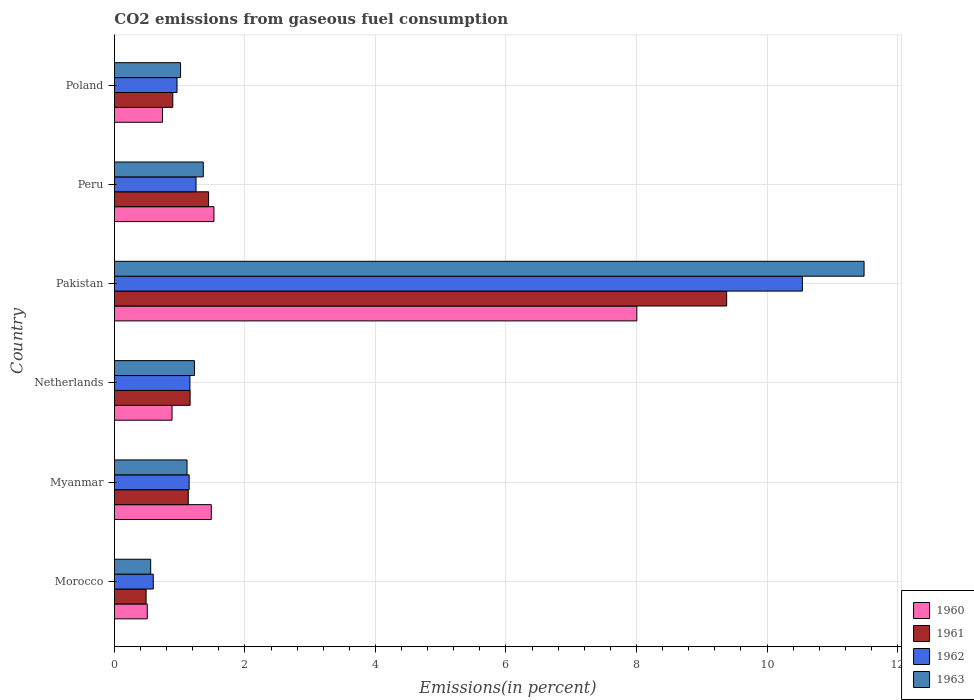Are the number of bars on each tick of the Y-axis equal?
Offer a very short reply. Yes. How many bars are there on the 1st tick from the bottom?
Provide a short and direct response. 4. What is the total CO2 emitted in 1962 in Myanmar?
Provide a short and direct response. 1.15. Across all countries, what is the maximum total CO2 emitted in 1961?
Provide a succinct answer. 9.38. Across all countries, what is the minimum total CO2 emitted in 1961?
Your response must be concise. 0.49. In which country was the total CO2 emitted in 1960 minimum?
Keep it short and to the point. Morocco. What is the total total CO2 emitted in 1960 in the graph?
Your answer should be compact. 13.14. What is the difference between the total CO2 emitted in 1960 in Netherlands and that in Poland?
Your answer should be compact. 0.15. What is the difference between the total CO2 emitted in 1960 in Morocco and the total CO2 emitted in 1963 in Poland?
Offer a very short reply. -0.51. What is the average total CO2 emitted in 1961 per country?
Make the answer very short. 2.42. What is the difference between the total CO2 emitted in 1961 and total CO2 emitted in 1960 in Pakistan?
Your response must be concise. 1.38. In how many countries, is the total CO2 emitted in 1963 greater than 7.6 %?
Your answer should be very brief. 1. What is the ratio of the total CO2 emitted in 1960 in Morocco to that in Peru?
Your answer should be very brief. 0.33. Is the total CO2 emitted in 1961 in Netherlands less than that in Peru?
Offer a terse response. Yes. Is the difference between the total CO2 emitted in 1961 in Morocco and Peru greater than the difference between the total CO2 emitted in 1960 in Morocco and Peru?
Ensure brevity in your answer.  Yes. What is the difference between the highest and the second highest total CO2 emitted in 1961?
Your answer should be very brief. 7.94. What is the difference between the highest and the lowest total CO2 emitted in 1962?
Ensure brevity in your answer.  9.95. In how many countries, is the total CO2 emitted in 1961 greater than the average total CO2 emitted in 1961 taken over all countries?
Give a very brief answer. 1. Is the sum of the total CO2 emitted in 1961 in Myanmar and Peru greater than the maximum total CO2 emitted in 1962 across all countries?
Give a very brief answer. No. What does the 1st bar from the top in Netherlands represents?
Offer a terse response. 1963. What does the 3rd bar from the bottom in Pakistan represents?
Offer a very short reply. 1962. Are the values on the major ticks of X-axis written in scientific E-notation?
Offer a very short reply. No. Where does the legend appear in the graph?
Offer a very short reply. Bottom right. How many legend labels are there?
Your answer should be compact. 4. What is the title of the graph?
Your response must be concise. CO2 emissions from gaseous fuel consumption. Does "1961" appear as one of the legend labels in the graph?
Give a very brief answer. Yes. What is the label or title of the X-axis?
Provide a short and direct response. Emissions(in percent). What is the label or title of the Y-axis?
Your response must be concise. Country. What is the Emissions(in percent) in 1960 in Morocco?
Keep it short and to the point. 0.5. What is the Emissions(in percent) of 1961 in Morocco?
Your answer should be very brief. 0.49. What is the Emissions(in percent) in 1962 in Morocco?
Your response must be concise. 0.6. What is the Emissions(in percent) of 1963 in Morocco?
Give a very brief answer. 0.56. What is the Emissions(in percent) of 1960 in Myanmar?
Offer a very short reply. 1.48. What is the Emissions(in percent) of 1961 in Myanmar?
Make the answer very short. 1.13. What is the Emissions(in percent) in 1962 in Myanmar?
Offer a very short reply. 1.15. What is the Emissions(in percent) in 1963 in Myanmar?
Provide a short and direct response. 1.11. What is the Emissions(in percent) of 1960 in Netherlands?
Provide a short and direct response. 0.88. What is the Emissions(in percent) of 1961 in Netherlands?
Ensure brevity in your answer.  1.16. What is the Emissions(in percent) of 1962 in Netherlands?
Ensure brevity in your answer.  1.16. What is the Emissions(in percent) in 1963 in Netherlands?
Give a very brief answer. 1.23. What is the Emissions(in percent) of 1960 in Pakistan?
Make the answer very short. 8.01. What is the Emissions(in percent) of 1961 in Pakistan?
Offer a very short reply. 9.38. What is the Emissions(in percent) of 1962 in Pakistan?
Your answer should be compact. 10.54. What is the Emissions(in percent) of 1963 in Pakistan?
Make the answer very short. 11.49. What is the Emissions(in percent) of 1960 in Peru?
Your answer should be very brief. 1.53. What is the Emissions(in percent) in 1961 in Peru?
Make the answer very short. 1.44. What is the Emissions(in percent) of 1962 in Peru?
Offer a terse response. 1.25. What is the Emissions(in percent) of 1963 in Peru?
Your answer should be very brief. 1.36. What is the Emissions(in percent) of 1960 in Poland?
Provide a short and direct response. 0.74. What is the Emissions(in percent) in 1961 in Poland?
Provide a succinct answer. 0.89. What is the Emissions(in percent) in 1962 in Poland?
Make the answer very short. 0.96. What is the Emissions(in percent) in 1963 in Poland?
Your answer should be very brief. 1.01. Across all countries, what is the maximum Emissions(in percent) of 1960?
Provide a short and direct response. 8.01. Across all countries, what is the maximum Emissions(in percent) of 1961?
Give a very brief answer. 9.38. Across all countries, what is the maximum Emissions(in percent) in 1962?
Make the answer very short. 10.54. Across all countries, what is the maximum Emissions(in percent) of 1963?
Give a very brief answer. 11.49. Across all countries, what is the minimum Emissions(in percent) of 1960?
Provide a succinct answer. 0.5. Across all countries, what is the minimum Emissions(in percent) in 1961?
Your response must be concise. 0.49. Across all countries, what is the minimum Emissions(in percent) in 1962?
Make the answer very short. 0.6. Across all countries, what is the minimum Emissions(in percent) of 1963?
Provide a succinct answer. 0.56. What is the total Emissions(in percent) of 1960 in the graph?
Give a very brief answer. 13.14. What is the total Emissions(in percent) in 1961 in the graph?
Provide a short and direct response. 14.5. What is the total Emissions(in percent) in 1962 in the graph?
Offer a terse response. 15.65. What is the total Emissions(in percent) of 1963 in the graph?
Give a very brief answer. 16.76. What is the difference between the Emissions(in percent) of 1960 in Morocco and that in Myanmar?
Provide a short and direct response. -0.98. What is the difference between the Emissions(in percent) in 1961 in Morocco and that in Myanmar?
Offer a terse response. -0.65. What is the difference between the Emissions(in percent) of 1962 in Morocco and that in Myanmar?
Provide a succinct answer. -0.55. What is the difference between the Emissions(in percent) in 1963 in Morocco and that in Myanmar?
Your answer should be very brief. -0.56. What is the difference between the Emissions(in percent) of 1960 in Morocco and that in Netherlands?
Offer a terse response. -0.38. What is the difference between the Emissions(in percent) of 1961 in Morocco and that in Netherlands?
Your answer should be compact. -0.67. What is the difference between the Emissions(in percent) of 1962 in Morocco and that in Netherlands?
Make the answer very short. -0.56. What is the difference between the Emissions(in percent) in 1963 in Morocco and that in Netherlands?
Ensure brevity in your answer.  -0.67. What is the difference between the Emissions(in percent) of 1960 in Morocco and that in Pakistan?
Your response must be concise. -7.5. What is the difference between the Emissions(in percent) of 1961 in Morocco and that in Pakistan?
Your answer should be very brief. -8.9. What is the difference between the Emissions(in percent) in 1962 in Morocco and that in Pakistan?
Provide a short and direct response. -9.95. What is the difference between the Emissions(in percent) of 1963 in Morocco and that in Pakistan?
Give a very brief answer. -10.93. What is the difference between the Emissions(in percent) of 1960 in Morocco and that in Peru?
Make the answer very short. -1.02. What is the difference between the Emissions(in percent) in 1961 in Morocco and that in Peru?
Give a very brief answer. -0.96. What is the difference between the Emissions(in percent) of 1962 in Morocco and that in Peru?
Provide a succinct answer. -0.66. What is the difference between the Emissions(in percent) of 1963 in Morocco and that in Peru?
Offer a terse response. -0.81. What is the difference between the Emissions(in percent) of 1960 in Morocco and that in Poland?
Your response must be concise. -0.23. What is the difference between the Emissions(in percent) in 1961 in Morocco and that in Poland?
Your response must be concise. -0.41. What is the difference between the Emissions(in percent) in 1962 in Morocco and that in Poland?
Your answer should be compact. -0.36. What is the difference between the Emissions(in percent) in 1963 in Morocco and that in Poland?
Give a very brief answer. -0.46. What is the difference between the Emissions(in percent) of 1960 in Myanmar and that in Netherlands?
Offer a very short reply. 0.6. What is the difference between the Emissions(in percent) of 1961 in Myanmar and that in Netherlands?
Your response must be concise. -0.03. What is the difference between the Emissions(in percent) in 1962 in Myanmar and that in Netherlands?
Offer a very short reply. -0.01. What is the difference between the Emissions(in percent) of 1963 in Myanmar and that in Netherlands?
Provide a short and direct response. -0.11. What is the difference between the Emissions(in percent) of 1960 in Myanmar and that in Pakistan?
Provide a short and direct response. -6.52. What is the difference between the Emissions(in percent) of 1961 in Myanmar and that in Pakistan?
Your answer should be compact. -8.25. What is the difference between the Emissions(in percent) of 1962 in Myanmar and that in Pakistan?
Provide a short and direct response. -9.4. What is the difference between the Emissions(in percent) of 1963 in Myanmar and that in Pakistan?
Your answer should be compact. -10.37. What is the difference between the Emissions(in percent) of 1960 in Myanmar and that in Peru?
Provide a succinct answer. -0.04. What is the difference between the Emissions(in percent) of 1961 in Myanmar and that in Peru?
Offer a very short reply. -0.31. What is the difference between the Emissions(in percent) of 1962 in Myanmar and that in Peru?
Keep it short and to the point. -0.11. What is the difference between the Emissions(in percent) of 1963 in Myanmar and that in Peru?
Keep it short and to the point. -0.25. What is the difference between the Emissions(in percent) of 1960 in Myanmar and that in Poland?
Make the answer very short. 0.75. What is the difference between the Emissions(in percent) of 1961 in Myanmar and that in Poland?
Ensure brevity in your answer.  0.24. What is the difference between the Emissions(in percent) of 1962 in Myanmar and that in Poland?
Your answer should be compact. 0.19. What is the difference between the Emissions(in percent) in 1963 in Myanmar and that in Poland?
Keep it short and to the point. 0.1. What is the difference between the Emissions(in percent) in 1960 in Netherlands and that in Pakistan?
Offer a very short reply. -7.12. What is the difference between the Emissions(in percent) of 1961 in Netherlands and that in Pakistan?
Give a very brief answer. -8.22. What is the difference between the Emissions(in percent) in 1962 in Netherlands and that in Pakistan?
Your answer should be very brief. -9.38. What is the difference between the Emissions(in percent) of 1963 in Netherlands and that in Pakistan?
Ensure brevity in your answer.  -10.26. What is the difference between the Emissions(in percent) of 1960 in Netherlands and that in Peru?
Provide a short and direct response. -0.64. What is the difference between the Emissions(in percent) in 1961 in Netherlands and that in Peru?
Provide a short and direct response. -0.28. What is the difference between the Emissions(in percent) of 1962 in Netherlands and that in Peru?
Your answer should be compact. -0.09. What is the difference between the Emissions(in percent) of 1963 in Netherlands and that in Peru?
Offer a terse response. -0.14. What is the difference between the Emissions(in percent) in 1960 in Netherlands and that in Poland?
Keep it short and to the point. 0.15. What is the difference between the Emissions(in percent) of 1961 in Netherlands and that in Poland?
Your answer should be very brief. 0.27. What is the difference between the Emissions(in percent) in 1962 in Netherlands and that in Poland?
Provide a short and direct response. 0.2. What is the difference between the Emissions(in percent) of 1963 in Netherlands and that in Poland?
Keep it short and to the point. 0.21. What is the difference between the Emissions(in percent) in 1960 in Pakistan and that in Peru?
Give a very brief answer. 6.48. What is the difference between the Emissions(in percent) in 1961 in Pakistan and that in Peru?
Your answer should be very brief. 7.94. What is the difference between the Emissions(in percent) of 1962 in Pakistan and that in Peru?
Ensure brevity in your answer.  9.29. What is the difference between the Emissions(in percent) in 1963 in Pakistan and that in Peru?
Give a very brief answer. 10.13. What is the difference between the Emissions(in percent) in 1960 in Pakistan and that in Poland?
Ensure brevity in your answer.  7.27. What is the difference between the Emissions(in percent) in 1961 in Pakistan and that in Poland?
Provide a succinct answer. 8.49. What is the difference between the Emissions(in percent) in 1962 in Pakistan and that in Poland?
Give a very brief answer. 9.58. What is the difference between the Emissions(in percent) of 1963 in Pakistan and that in Poland?
Give a very brief answer. 10.47. What is the difference between the Emissions(in percent) in 1960 in Peru and that in Poland?
Keep it short and to the point. 0.79. What is the difference between the Emissions(in percent) in 1961 in Peru and that in Poland?
Make the answer very short. 0.55. What is the difference between the Emissions(in percent) of 1962 in Peru and that in Poland?
Your response must be concise. 0.29. What is the difference between the Emissions(in percent) of 1963 in Peru and that in Poland?
Make the answer very short. 0.35. What is the difference between the Emissions(in percent) of 1960 in Morocco and the Emissions(in percent) of 1961 in Myanmar?
Make the answer very short. -0.63. What is the difference between the Emissions(in percent) in 1960 in Morocco and the Emissions(in percent) in 1962 in Myanmar?
Give a very brief answer. -0.64. What is the difference between the Emissions(in percent) in 1960 in Morocco and the Emissions(in percent) in 1963 in Myanmar?
Provide a succinct answer. -0.61. What is the difference between the Emissions(in percent) of 1961 in Morocco and the Emissions(in percent) of 1962 in Myanmar?
Ensure brevity in your answer.  -0.66. What is the difference between the Emissions(in percent) of 1961 in Morocco and the Emissions(in percent) of 1963 in Myanmar?
Your response must be concise. -0.63. What is the difference between the Emissions(in percent) of 1962 in Morocco and the Emissions(in percent) of 1963 in Myanmar?
Offer a very short reply. -0.52. What is the difference between the Emissions(in percent) of 1960 in Morocco and the Emissions(in percent) of 1961 in Netherlands?
Offer a terse response. -0.66. What is the difference between the Emissions(in percent) of 1960 in Morocco and the Emissions(in percent) of 1962 in Netherlands?
Your answer should be compact. -0.65. What is the difference between the Emissions(in percent) of 1960 in Morocco and the Emissions(in percent) of 1963 in Netherlands?
Provide a succinct answer. -0.72. What is the difference between the Emissions(in percent) in 1961 in Morocco and the Emissions(in percent) in 1962 in Netherlands?
Provide a short and direct response. -0.67. What is the difference between the Emissions(in percent) in 1961 in Morocco and the Emissions(in percent) in 1963 in Netherlands?
Offer a very short reply. -0.74. What is the difference between the Emissions(in percent) of 1962 in Morocco and the Emissions(in percent) of 1963 in Netherlands?
Your response must be concise. -0.63. What is the difference between the Emissions(in percent) in 1960 in Morocco and the Emissions(in percent) in 1961 in Pakistan?
Provide a succinct answer. -8.88. What is the difference between the Emissions(in percent) of 1960 in Morocco and the Emissions(in percent) of 1962 in Pakistan?
Give a very brief answer. -10.04. What is the difference between the Emissions(in percent) in 1960 in Morocco and the Emissions(in percent) in 1963 in Pakistan?
Your response must be concise. -10.98. What is the difference between the Emissions(in percent) in 1961 in Morocco and the Emissions(in percent) in 1962 in Pakistan?
Your answer should be compact. -10.06. What is the difference between the Emissions(in percent) of 1961 in Morocco and the Emissions(in percent) of 1963 in Pakistan?
Provide a short and direct response. -11. What is the difference between the Emissions(in percent) of 1962 in Morocco and the Emissions(in percent) of 1963 in Pakistan?
Your answer should be compact. -10.89. What is the difference between the Emissions(in percent) in 1960 in Morocco and the Emissions(in percent) in 1961 in Peru?
Make the answer very short. -0.94. What is the difference between the Emissions(in percent) of 1960 in Morocco and the Emissions(in percent) of 1962 in Peru?
Offer a very short reply. -0.75. What is the difference between the Emissions(in percent) of 1960 in Morocco and the Emissions(in percent) of 1963 in Peru?
Your response must be concise. -0.86. What is the difference between the Emissions(in percent) of 1961 in Morocco and the Emissions(in percent) of 1962 in Peru?
Provide a succinct answer. -0.77. What is the difference between the Emissions(in percent) of 1961 in Morocco and the Emissions(in percent) of 1963 in Peru?
Your answer should be very brief. -0.88. What is the difference between the Emissions(in percent) in 1962 in Morocco and the Emissions(in percent) in 1963 in Peru?
Your answer should be compact. -0.77. What is the difference between the Emissions(in percent) of 1960 in Morocco and the Emissions(in percent) of 1961 in Poland?
Give a very brief answer. -0.39. What is the difference between the Emissions(in percent) in 1960 in Morocco and the Emissions(in percent) in 1962 in Poland?
Provide a short and direct response. -0.46. What is the difference between the Emissions(in percent) in 1960 in Morocco and the Emissions(in percent) in 1963 in Poland?
Your response must be concise. -0.51. What is the difference between the Emissions(in percent) of 1961 in Morocco and the Emissions(in percent) of 1962 in Poland?
Provide a short and direct response. -0.47. What is the difference between the Emissions(in percent) in 1961 in Morocco and the Emissions(in percent) in 1963 in Poland?
Make the answer very short. -0.53. What is the difference between the Emissions(in percent) of 1962 in Morocco and the Emissions(in percent) of 1963 in Poland?
Keep it short and to the point. -0.42. What is the difference between the Emissions(in percent) of 1960 in Myanmar and the Emissions(in percent) of 1961 in Netherlands?
Your response must be concise. 0.32. What is the difference between the Emissions(in percent) of 1960 in Myanmar and the Emissions(in percent) of 1962 in Netherlands?
Offer a terse response. 0.33. What is the difference between the Emissions(in percent) of 1960 in Myanmar and the Emissions(in percent) of 1963 in Netherlands?
Keep it short and to the point. 0.26. What is the difference between the Emissions(in percent) of 1961 in Myanmar and the Emissions(in percent) of 1962 in Netherlands?
Your answer should be very brief. -0.03. What is the difference between the Emissions(in percent) in 1961 in Myanmar and the Emissions(in percent) in 1963 in Netherlands?
Give a very brief answer. -0.09. What is the difference between the Emissions(in percent) of 1962 in Myanmar and the Emissions(in percent) of 1963 in Netherlands?
Offer a terse response. -0.08. What is the difference between the Emissions(in percent) of 1960 in Myanmar and the Emissions(in percent) of 1961 in Pakistan?
Offer a terse response. -7.9. What is the difference between the Emissions(in percent) in 1960 in Myanmar and the Emissions(in percent) in 1962 in Pakistan?
Your response must be concise. -9.06. What is the difference between the Emissions(in percent) in 1960 in Myanmar and the Emissions(in percent) in 1963 in Pakistan?
Give a very brief answer. -10. What is the difference between the Emissions(in percent) in 1961 in Myanmar and the Emissions(in percent) in 1962 in Pakistan?
Offer a terse response. -9.41. What is the difference between the Emissions(in percent) in 1961 in Myanmar and the Emissions(in percent) in 1963 in Pakistan?
Ensure brevity in your answer.  -10.36. What is the difference between the Emissions(in percent) in 1962 in Myanmar and the Emissions(in percent) in 1963 in Pakistan?
Offer a terse response. -10.34. What is the difference between the Emissions(in percent) of 1960 in Myanmar and the Emissions(in percent) of 1961 in Peru?
Your response must be concise. 0.04. What is the difference between the Emissions(in percent) of 1960 in Myanmar and the Emissions(in percent) of 1962 in Peru?
Give a very brief answer. 0.23. What is the difference between the Emissions(in percent) of 1960 in Myanmar and the Emissions(in percent) of 1963 in Peru?
Offer a terse response. 0.12. What is the difference between the Emissions(in percent) of 1961 in Myanmar and the Emissions(in percent) of 1962 in Peru?
Keep it short and to the point. -0.12. What is the difference between the Emissions(in percent) in 1961 in Myanmar and the Emissions(in percent) in 1963 in Peru?
Your answer should be compact. -0.23. What is the difference between the Emissions(in percent) in 1962 in Myanmar and the Emissions(in percent) in 1963 in Peru?
Provide a short and direct response. -0.22. What is the difference between the Emissions(in percent) in 1960 in Myanmar and the Emissions(in percent) in 1961 in Poland?
Provide a short and direct response. 0.59. What is the difference between the Emissions(in percent) of 1960 in Myanmar and the Emissions(in percent) of 1962 in Poland?
Provide a short and direct response. 0.53. What is the difference between the Emissions(in percent) in 1960 in Myanmar and the Emissions(in percent) in 1963 in Poland?
Keep it short and to the point. 0.47. What is the difference between the Emissions(in percent) of 1961 in Myanmar and the Emissions(in percent) of 1962 in Poland?
Make the answer very short. 0.17. What is the difference between the Emissions(in percent) in 1961 in Myanmar and the Emissions(in percent) in 1963 in Poland?
Your answer should be very brief. 0.12. What is the difference between the Emissions(in percent) in 1962 in Myanmar and the Emissions(in percent) in 1963 in Poland?
Your response must be concise. 0.13. What is the difference between the Emissions(in percent) in 1960 in Netherlands and the Emissions(in percent) in 1961 in Pakistan?
Make the answer very short. -8.5. What is the difference between the Emissions(in percent) in 1960 in Netherlands and the Emissions(in percent) in 1962 in Pakistan?
Offer a very short reply. -9.66. What is the difference between the Emissions(in percent) of 1960 in Netherlands and the Emissions(in percent) of 1963 in Pakistan?
Give a very brief answer. -10.6. What is the difference between the Emissions(in percent) of 1961 in Netherlands and the Emissions(in percent) of 1962 in Pakistan?
Keep it short and to the point. -9.38. What is the difference between the Emissions(in percent) in 1961 in Netherlands and the Emissions(in percent) in 1963 in Pakistan?
Offer a very short reply. -10.33. What is the difference between the Emissions(in percent) in 1962 in Netherlands and the Emissions(in percent) in 1963 in Pakistan?
Give a very brief answer. -10.33. What is the difference between the Emissions(in percent) of 1960 in Netherlands and the Emissions(in percent) of 1961 in Peru?
Make the answer very short. -0.56. What is the difference between the Emissions(in percent) in 1960 in Netherlands and the Emissions(in percent) in 1962 in Peru?
Offer a terse response. -0.37. What is the difference between the Emissions(in percent) in 1960 in Netherlands and the Emissions(in percent) in 1963 in Peru?
Give a very brief answer. -0.48. What is the difference between the Emissions(in percent) of 1961 in Netherlands and the Emissions(in percent) of 1962 in Peru?
Offer a terse response. -0.09. What is the difference between the Emissions(in percent) of 1961 in Netherlands and the Emissions(in percent) of 1963 in Peru?
Keep it short and to the point. -0.2. What is the difference between the Emissions(in percent) of 1962 in Netherlands and the Emissions(in percent) of 1963 in Peru?
Make the answer very short. -0.2. What is the difference between the Emissions(in percent) of 1960 in Netherlands and the Emissions(in percent) of 1961 in Poland?
Provide a short and direct response. -0.01. What is the difference between the Emissions(in percent) in 1960 in Netherlands and the Emissions(in percent) in 1962 in Poland?
Ensure brevity in your answer.  -0.08. What is the difference between the Emissions(in percent) in 1960 in Netherlands and the Emissions(in percent) in 1963 in Poland?
Offer a very short reply. -0.13. What is the difference between the Emissions(in percent) in 1961 in Netherlands and the Emissions(in percent) in 1962 in Poland?
Provide a succinct answer. 0.2. What is the difference between the Emissions(in percent) in 1961 in Netherlands and the Emissions(in percent) in 1963 in Poland?
Keep it short and to the point. 0.15. What is the difference between the Emissions(in percent) of 1962 in Netherlands and the Emissions(in percent) of 1963 in Poland?
Offer a very short reply. 0.14. What is the difference between the Emissions(in percent) in 1960 in Pakistan and the Emissions(in percent) in 1961 in Peru?
Your response must be concise. 6.56. What is the difference between the Emissions(in percent) in 1960 in Pakistan and the Emissions(in percent) in 1962 in Peru?
Your answer should be compact. 6.75. What is the difference between the Emissions(in percent) of 1960 in Pakistan and the Emissions(in percent) of 1963 in Peru?
Make the answer very short. 6.64. What is the difference between the Emissions(in percent) of 1961 in Pakistan and the Emissions(in percent) of 1962 in Peru?
Provide a succinct answer. 8.13. What is the difference between the Emissions(in percent) of 1961 in Pakistan and the Emissions(in percent) of 1963 in Peru?
Make the answer very short. 8.02. What is the difference between the Emissions(in percent) of 1962 in Pakistan and the Emissions(in percent) of 1963 in Peru?
Ensure brevity in your answer.  9.18. What is the difference between the Emissions(in percent) of 1960 in Pakistan and the Emissions(in percent) of 1961 in Poland?
Keep it short and to the point. 7.11. What is the difference between the Emissions(in percent) in 1960 in Pakistan and the Emissions(in percent) in 1962 in Poland?
Ensure brevity in your answer.  7.05. What is the difference between the Emissions(in percent) in 1960 in Pakistan and the Emissions(in percent) in 1963 in Poland?
Offer a terse response. 6.99. What is the difference between the Emissions(in percent) in 1961 in Pakistan and the Emissions(in percent) in 1962 in Poland?
Offer a very short reply. 8.42. What is the difference between the Emissions(in percent) of 1961 in Pakistan and the Emissions(in percent) of 1963 in Poland?
Keep it short and to the point. 8.37. What is the difference between the Emissions(in percent) of 1962 in Pakistan and the Emissions(in percent) of 1963 in Poland?
Your answer should be compact. 9.53. What is the difference between the Emissions(in percent) in 1960 in Peru and the Emissions(in percent) in 1961 in Poland?
Your answer should be very brief. 0.63. What is the difference between the Emissions(in percent) of 1960 in Peru and the Emissions(in percent) of 1962 in Poland?
Ensure brevity in your answer.  0.57. What is the difference between the Emissions(in percent) of 1960 in Peru and the Emissions(in percent) of 1963 in Poland?
Your answer should be very brief. 0.51. What is the difference between the Emissions(in percent) in 1961 in Peru and the Emissions(in percent) in 1962 in Poland?
Your answer should be compact. 0.48. What is the difference between the Emissions(in percent) of 1961 in Peru and the Emissions(in percent) of 1963 in Poland?
Ensure brevity in your answer.  0.43. What is the difference between the Emissions(in percent) of 1962 in Peru and the Emissions(in percent) of 1963 in Poland?
Offer a very short reply. 0.24. What is the average Emissions(in percent) in 1960 per country?
Your answer should be very brief. 2.19. What is the average Emissions(in percent) of 1961 per country?
Your answer should be compact. 2.42. What is the average Emissions(in percent) of 1962 per country?
Your response must be concise. 2.61. What is the average Emissions(in percent) of 1963 per country?
Provide a succinct answer. 2.79. What is the difference between the Emissions(in percent) of 1960 and Emissions(in percent) of 1961 in Morocco?
Keep it short and to the point. 0.02. What is the difference between the Emissions(in percent) in 1960 and Emissions(in percent) in 1962 in Morocco?
Keep it short and to the point. -0.09. What is the difference between the Emissions(in percent) in 1960 and Emissions(in percent) in 1963 in Morocco?
Your response must be concise. -0.05. What is the difference between the Emissions(in percent) in 1961 and Emissions(in percent) in 1962 in Morocco?
Your answer should be compact. -0.11. What is the difference between the Emissions(in percent) of 1961 and Emissions(in percent) of 1963 in Morocco?
Offer a very short reply. -0.07. What is the difference between the Emissions(in percent) of 1962 and Emissions(in percent) of 1963 in Morocco?
Make the answer very short. 0.04. What is the difference between the Emissions(in percent) in 1960 and Emissions(in percent) in 1961 in Myanmar?
Provide a succinct answer. 0.35. What is the difference between the Emissions(in percent) of 1960 and Emissions(in percent) of 1962 in Myanmar?
Your response must be concise. 0.34. What is the difference between the Emissions(in percent) in 1960 and Emissions(in percent) in 1963 in Myanmar?
Provide a short and direct response. 0.37. What is the difference between the Emissions(in percent) of 1961 and Emissions(in percent) of 1962 in Myanmar?
Your response must be concise. -0.01. What is the difference between the Emissions(in percent) in 1961 and Emissions(in percent) in 1963 in Myanmar?
Your answer should be very brief. 0.02. What is the difference between the Emissions(in percent) of 1962 and Emissions(in percent) of 1963 in Myanmar?
Ensure brevity in your answer.  0.03. What is the difference between the Emissions(in percent) of 1960 and Emissions(in percent) of 1961 in Netherlands?
Make the answer very short. -0.28. What is the difference between the Emissions(in percent) in 1960 and Emissions(in percent) in 1962 in Netherlands?
Offer a very short reply. -0.27. What is the difference between the Emissions(in percent) in 1960 and Emissions(in percent) in 1963 in Netherlands?
Offer a terse response. -0.34. What is the difference between the Emissions(in percent) of 1961 and Emissions(in percent) of 1962 in Netherlands?
Make the answer very short. 0. What is the difference between the Emissions(in percent) of 1961 and Emissions(in percent) of 1963 in Netherlands?
Ensure brevity in your answer.  -0.07. What is the difference between the Emissions(in percent) in 1962 and Emissions(in percent) in 1963 in Netherlands?
Your answer should be very brief. -0.07. What is the difference between the Emissions(in percent) of 1960 and Emissions(in percent) of 1961 in Pakistan?
Provide a succinct answer. -1.38. What is the difference between the Emissions(in percent) of 1960 and Emissions(in percent) of 1962 in Pakistan?
Your answer should be very brief. -2.54. What is the difference between the Emissions(in percent) in 1960 and Emissions(in percent) in 1963 in Pakistan?
Offer a terse response. -3.48. What is the difference between the Emissions(in percent) in 1961 and Emissions(in percent) in 1962 in Pakistan?
Offer a very short reply. -1.16. What is the difference between the Emissions(in percent) of 1961 and Emissions(in percent) of 1963 in Pakistan?
Ensure brevity in your answer.  -2.11. What is the difference between the Emissions(in percent) of 1962 and Emissions(in percent) of 1963 in Pakistan?
Provide a short and direct response. -0.95. What is the difference between the Emissions(in percent) of 1960 and Emissions(in percent) of 1961 in Peru?
Your answer should be very brief. 0.08. What is the difference between the Emissions(in percent) of 1960 and Emissions(in percent) of 1962 in Peru?
Provide a succinct answer. 0.27. What is the difference between the Emissions(in percent) of 1960 and Emissions(in percent) of 1963 in Peru?
Your response must be concise. 0.16. What is the difference between the Emissions(in percent) in 1961 and Emissions(in percent) in 1962 in Peru?
Provide a short and direct response. 0.19. What is the difference between the Emissions(in percent) in 1961 and Emissions(in percent) in 1963 in Peru?
Keep it short and to the point. 0.08. What is the difference between the Emissions(in percent) of 1962 and Emissions(in percent) of 1963 in Peru?
Ensure brevity in your answer.  -0.11. What is the difference between the Emissions(in percent) of 1960 and Emissions(in percent) of 1961 in Poland?
Ensure brevity in your answer.  -0.16. What is the difference between the Emissions(in percent) in 1960 and Emissions(in percent) in 1962 in Poland?
Keep it short and to the point. -0.22. What is the difference between the Emissions(in percent) in 1960 and Emissions(in percent) in 1963 in Poland?
Provide a short and direct response. -0.28. What is the difference between the Emissions(in percent) of 1961 and Emissions(in percent) of 1962 in Poland?
Your answer should be very brief. -0.06. What is the difference between the Emissions(in percent) of 1961 and Emissions(in percent) of 1963 in Poland?
Your response must be concise. -0.12. What is the difference between the Emissions(in percent) in 1962 and Emissions(in percent) in 1963 in Poland?
Keep it short and to the point. -0.05. What is the ratio of the Emissions(in percent) of 1960 in Morocco to that in Myanmar?
Keep it short and to the point. 0.34. What is the ratio of the Emissions(in percent) of 1961 in Morocco to that in Myanmar?
Your answer should be very brief. 0.43. What is the ratio of the Emissions(in percent) of 1962 in Morocco to that in Myanmar?
Your answer should be compact. 0.52. What is the ratio of the Emissions(in percent) in 1963 in Morocco to that in Myanmar?
Offer a terse response. 0.5. What is the ratio of the Emissions(in percent) in 1960 in Morocco to that in Netherlands?
Provide a succinct answer. 0.57. What is the ratio of the Emissions(in percent) of 1961 in Morocco to that in Netherlands?
Give a very brief answer. 0.42. What is the ratio of the Emissions(in percent) of 1962 in Morocco to that in Netherlands?
Make the answer very short. 0.51. What is the ratio of the Emissions(in percent) in 1963 in Morocco to that in Netherlands?
Provide a short and direct response. 0.45. What is the ratio of the Emissions(in percent) of 1960 in Morocco to that in Pakistan?
Give a very brief answer. 0.06. What is the ratio of the Emissions(in percent) of 1961 in Morocco to that in Pakistan?
Offer a terse response. 0.05. What is the ratio of the Emissions(in percent) in 1962 in Morocco to that in Pakistan?
Provide a succinct answer. 0.06. What is the ratio of the Emissions(in percent) of 1963 in Morocco to that in Pakistan?
Provide a short and direct response. 0.05. What is the ratio of the Emissions(in percent) of 1960 in Morocco to that in Peru?
Your answer should be very brief. 0.33. What is the ratio of the Emissions(in percent) in 1961 in Morocco to that in Peru?
Ensure brevity in your answer.  0.34. What is the ratio of the Emissions(in percent) of 1962 in Morocco to that in Peru?
Ensure brevity in your answer.  0.48. What is the ratio of the Emissions(in percent) of 1963 in Morocco to that in Peru?
Give a very brief answer. 0.41. What is the ratio of the Emissions(in percent) in 1960 in Morocco to that in Poland?
Offer a very short reply. 0.68. What is the ratio of the Emissions(in percent) in 1961 in Morocco to that in Poland?
Your response must be concise. 0.54. What is the ratio of the Emissions(in percent) of 1962 in Morocco to that in Poland?
Provide a succinct answer. 0.62. What is the ratio of the Emissions(in percent) of 1963 in Morocco to that in Poland?
Your response must be concise. 0.55. What is the ratio of the Emissions(in percent) of 1960 in Myanmar to that in Netherlands?
Make the answer very short. 1.68. What is the ratio of the Emissions(in percent) of 1961 in Myanmar to that in Netherlands?
Offer a terse response. 0.98. What is the ratio of the Emissions(in percent) in 1962 in Myanmar to that in Netherlands?
Your answer should be compact. 0.99. What is the ratio of the Emissions(in percent) in 1963 in Myanmar to that in Netherlands?
Ensure brevity in your answer.  0.91. What is the ratio of the Emissions(in percent) of 1960 in Myanmar to that in Pakistan?
Your answer should be very brief. 0.19. What is the ratio of the Emissions(in percent) of 1961 in Myanmar to that in Pakistan?
Provide a short and direct response. 0.12. What is the ratio of the Emissions(in percent) in 1962 in Myanmar to that in Pakistan?
Give a very brief answer. 0.11. What is the ratio of the Emissions(in percent) of 1963 in Myanmar to that in Pakistan?
Give a very brief answer. 0.1. What is the ratio of the Emissions(in percent) in 1960 in Myanmar to that in Peru?
Offer a very short reply. 0.97. What is the ratio of the Emissions(in percent) of 1961 in Myanmar to that in Peru?
Make the answer very short. 0.78. What is the ratio of the Emissions(in percent) of 1962 in Myanmar to that in Peru?
Give a very brief answer. 0.92. What is the ratio of the Emissions(in percent) of 1963 in Myanmar to that in Peru?
Make the answer very short. 0.82. What is the ratio of the Emissions(in percent) in 1960 in Myanmar to that in Poland?
Your answer should be compact. 2.02. What is the ratio of the Emissions(in percent) of 1961 in Myanmar to that in Poland?
Offer a very short reply. 1.26. What is the ratio of the Emissions(in percent) in 1962 in Myanmar to that in Poland?
Your response must be concise. 1.19. What is the ratio of the Emissions(in percent) of 1963 in Myanmar to that in Poland?
Provide a short and direct response. 1.1. What is the ratio of the Emissions(in percent) in 1960 in Netherlands to that in Pakistan?
Provide a succinct answer. 0.11. What is the ratio of the Emissions(in percent) of 1961 in Netherlands to that in Pakistan?
Provide a short and direct response. 0.12. What is the ratio of the Emissions(in percent) in 1962 in Netherlands to that in Pakistan?
Your response must be concise. 0.11. What is the ratio of the Emissions(in percent) of 1963 in Netherlands to that in Pakistan?
Make the answer very short. 0.11. What is the ratio of the Emissions(in percent) in 1960 in Netherlands to that in Peru?
Keep it short and to the point. 0.58. What is the ratio of the Emissions(in percent) of 1961 in Netherlands to that in Peru?
Provide a succinct answer. 0.8. What is the ratio of the Emissions(in percent) in 1962 in Netherlands to that in Peru?
Offer a terse response. 0.93. What is the ratio of the Emissions(in percent) of 1963 in Netherlands to that in Peru?
Give a very brief answer. 0.9. What is the ratio of the Emissions(in percent) in 1960 in Netherlands to that in Poland?
Ensure brevity in your answer.  1.2. What is the ratio of the Emissions(in percent) in 1961 in Netherlands to that in Poland?
Make the answer very short. 1.3. What is the ratio of the Emissions(in percent) in 1962 in Netherlands to that in Poland?
Make the answer very short. 1.21. What is the ratio of the Emissions(in percent) of 1963 in Netherlands to that in Poland?
Your answer should be very brief. 1.21. What is the ratio of the Emissions(in percent) in 1960 in Pakistan to that in Peru?
Provide a short and direct response. 5.25. What is the ratio of the Emissions(in percent) of 1961 in Pakistan to that in Peru?
Provide a short and direct response. 6.5. What is the ratio of the Emissions(in percent) in 1962 in Pakistan to that in Peru?
Offer a very short reply. 8.43. What is the ratio of the Emissions(in percent) of 1963 in Pakistan to that in Peru?
Your response must be concise. 8.44. What is the ratio of the Emissions(in percent) in 1960 in Pakistan to that in Poland?
Your response must be concise. 10.88. What is the ratio of the Emissions(in percent) of 1961 in Pakistan to that in Poland?
Ensure brevity in your answer.  10.49. What is the ratio of the Emissions(in percent) in 1962 in Pakistan to that in Poland?
Give a very brief answer. 10.99. What is the ratio of the Emissions(in percent) of 1963 in Pakistan to that in Poland?
Offer a very short reply. 11.34. What is the ratio of the Emissions(in percent) of 1960 in Peru to that in Poland?
Provide a short and direct response. 2.07. What is the ratio of the Emissions(in percent) in 1961 in Peru to that in Poland?
Provide a succinct answer. 1.61. What is the ratio of the Emissions(in percent) in 1962 in Peru to that in Poland?
Provide a short and direct response. 1.3. What is the ratio of the Emissions(in percent) of 1963 in Peru to that in Poland?
Give a very brief answer. 1.34. What is the difference between the highest and the second highest Emissions(in percent) in 1960?
Provide a succinct answer. 6.48. What is the difference between the highest and the second highest Emissions(in percent) of 1961?
Ensure brevity in your answer.  7.94. What is the difference between the highest and the second highest Emissions(in percent) in 1962?
Offer a terse response. 9.29. What is the difference between the highest and the second highest Emissions(in percent) in 1963?
Your response must be concise. 10.13. What is the difference between the highest and the lowest Emissions(in percent) of 1960?
Your response must be concise. 7.5. What is the difference between the highest and the lowest Emissions(in percent) of 1961?
Keep it short and to the point. 8.9. What is the difference between the highest and the lowest Emissions(in percent) of 1962?
Your answer should be compact. 9.95. What is the difference between the highest and the lowest Emissions(in percent) in 1963?
Give a very brief answer. 10.93. 